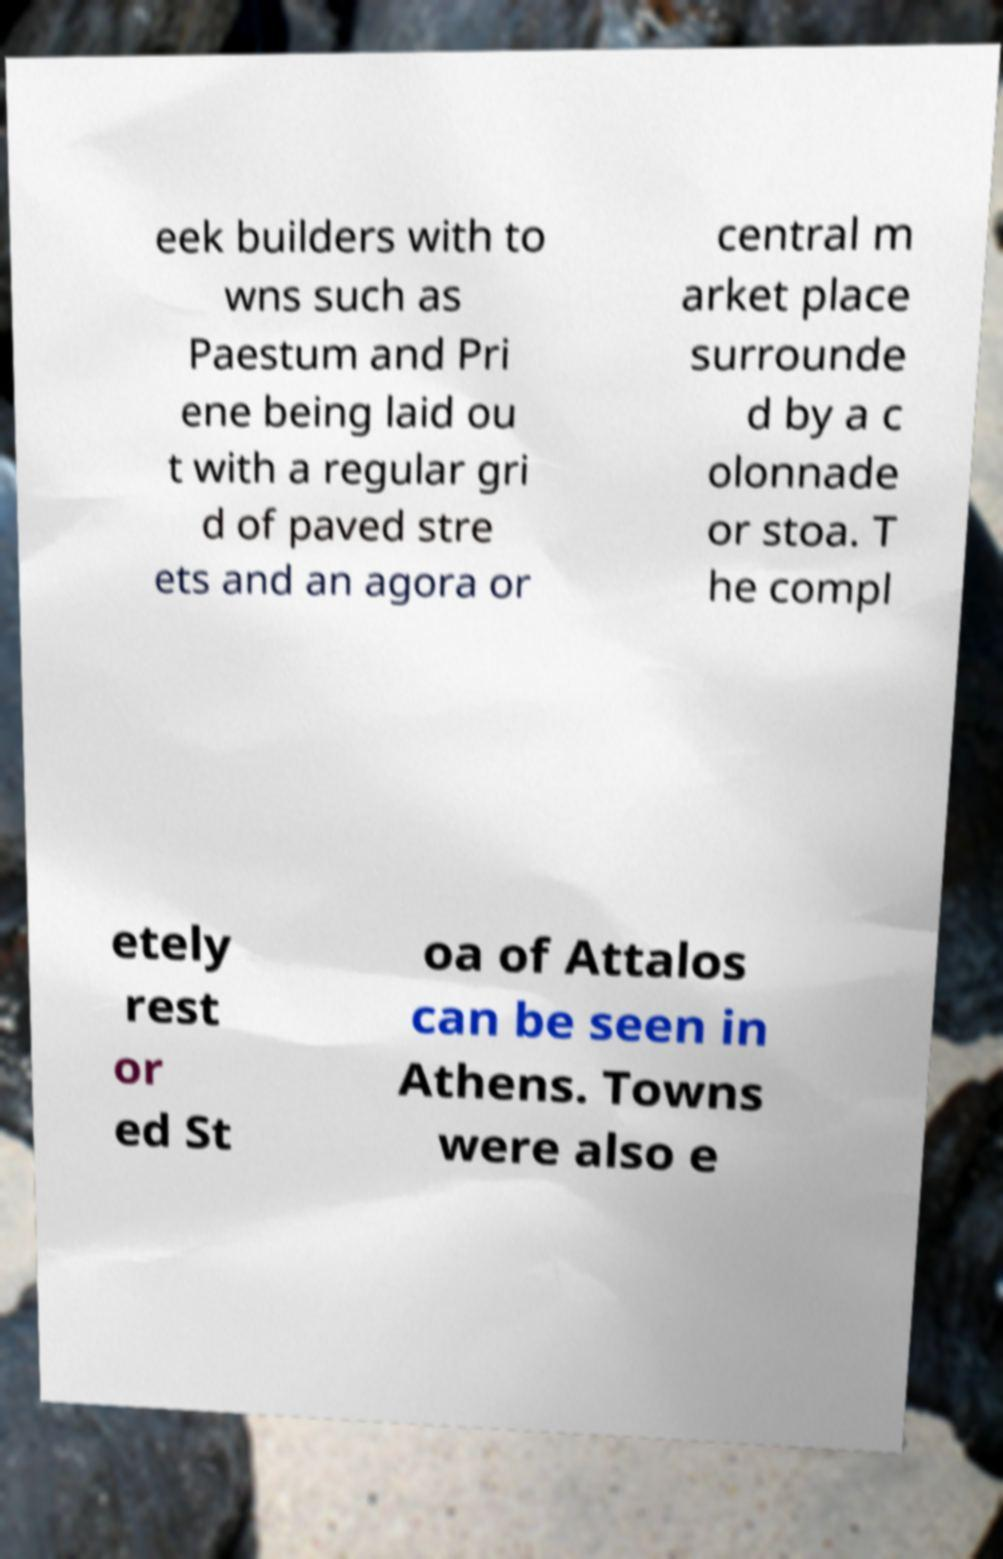Could you extract and type out the text from this image? eek builders with to wns such as Paestum and Pri ene being laid ou t with a regular gri d of paved stre ets and an agora or central m arket place surrounde d by a c olonnade or stoa. T he compl etely rest or ed St oa of Attalos can be seen in Athens. Towns were also e 